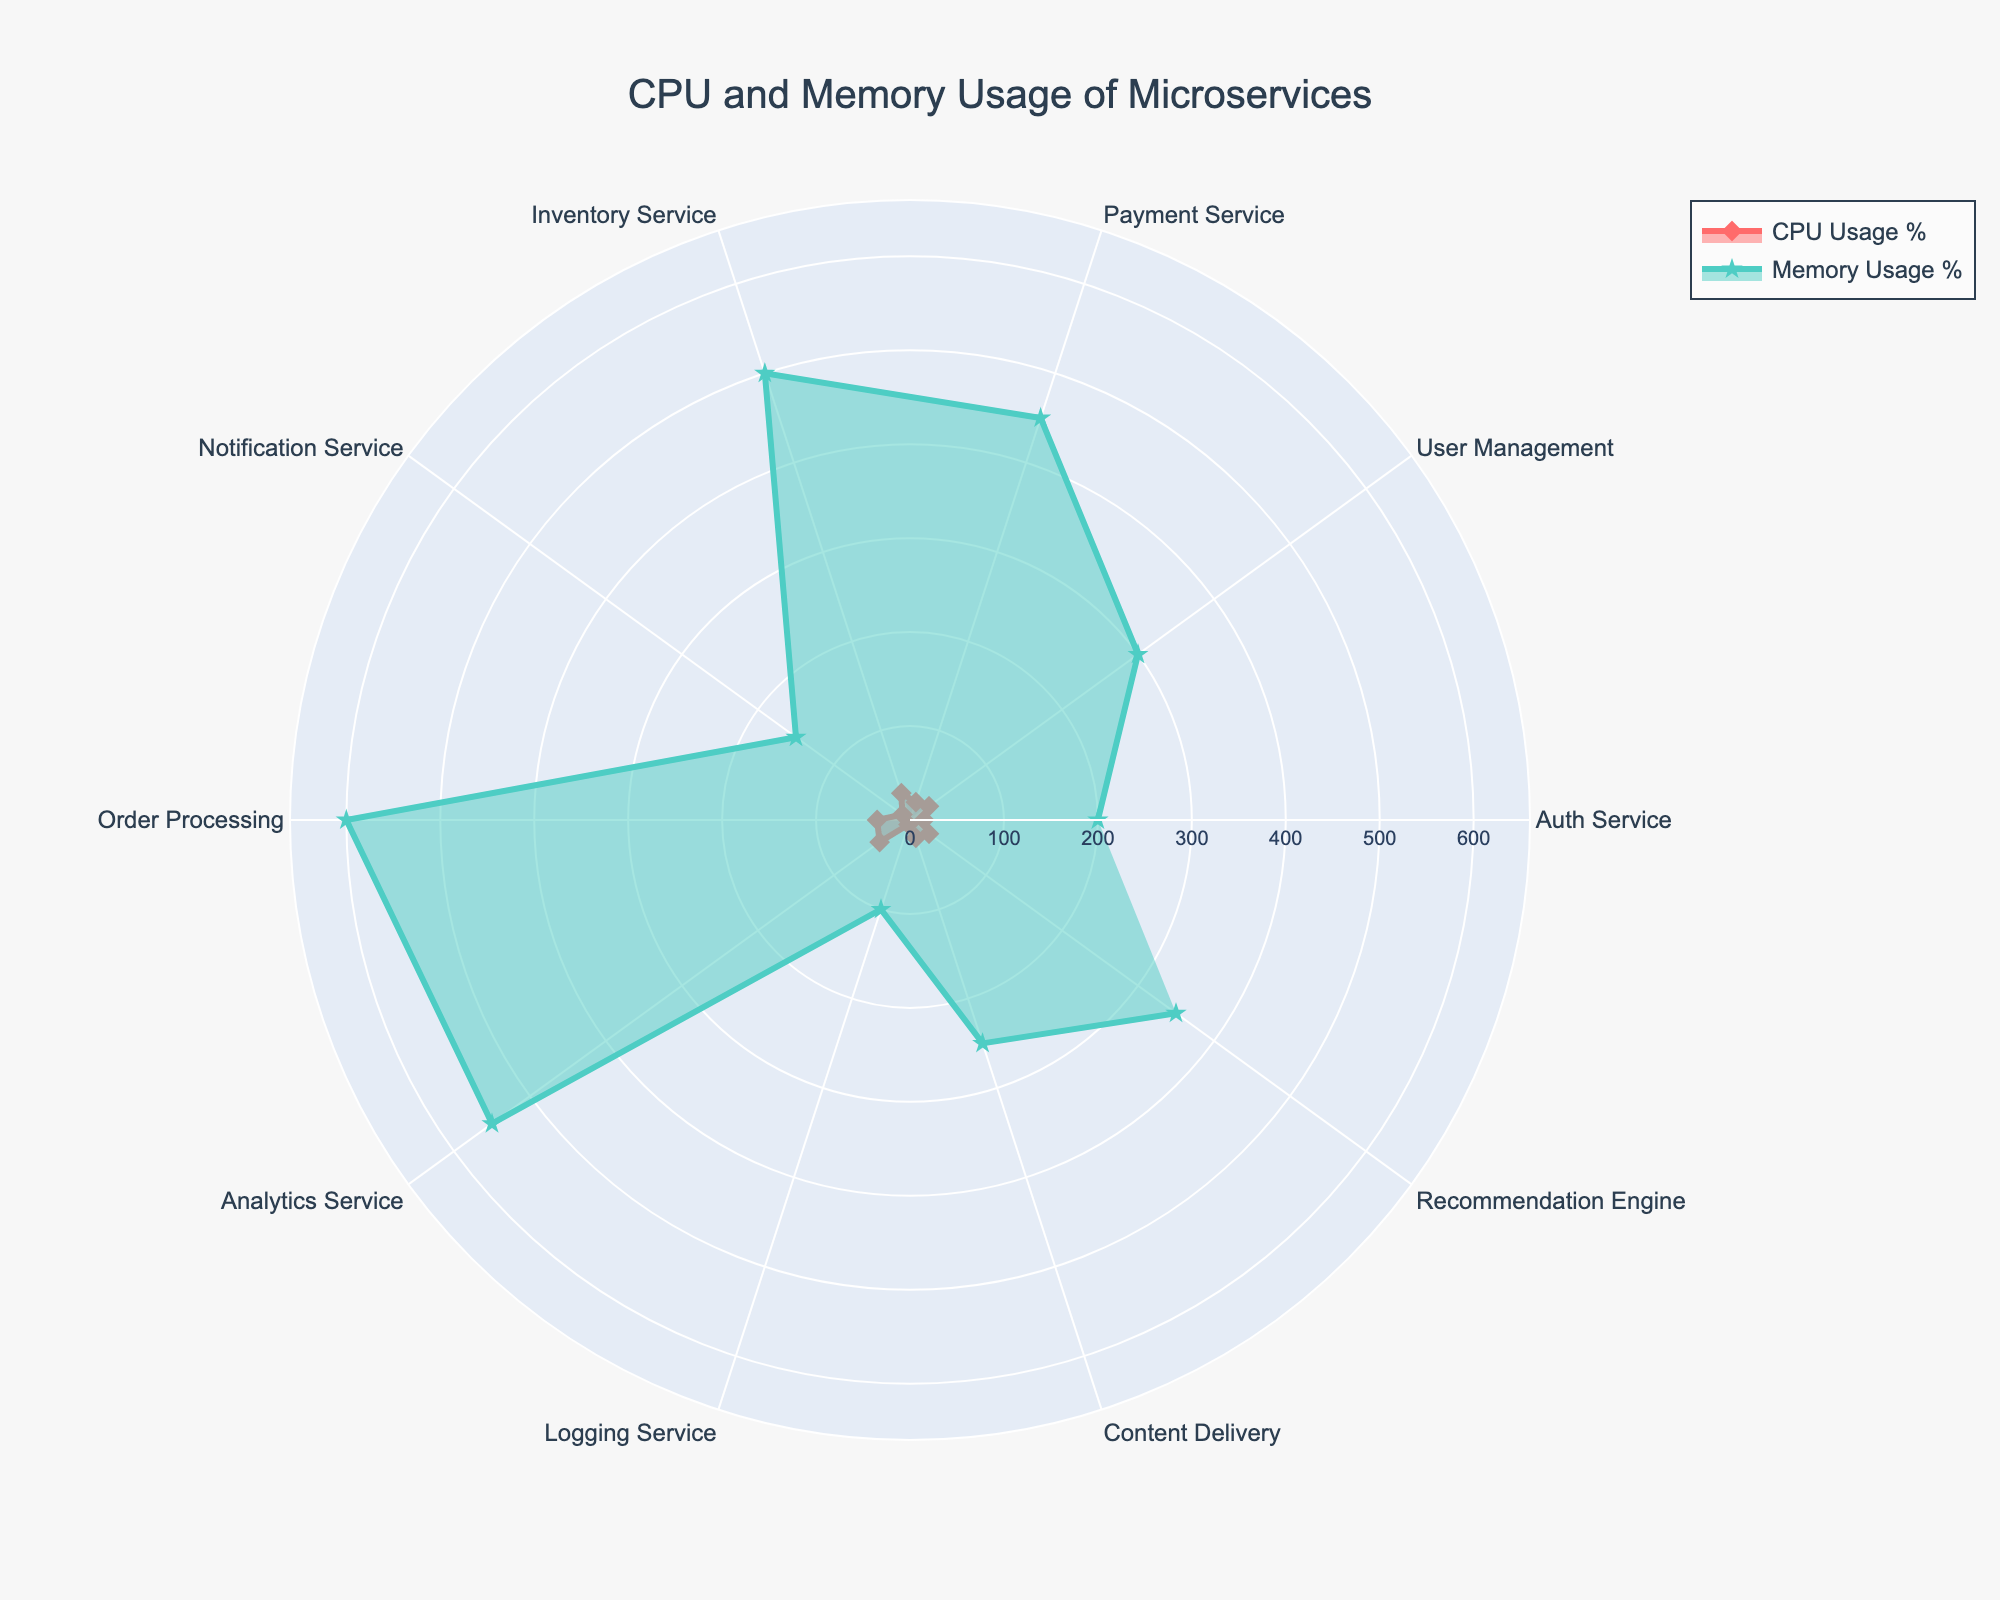What's the title of the radar chart? The title is located at the top center of the figure, typically larger in size than other text. It reads 'CPU and Memory Usage of Microservices'.
Answer: CPU and Memory Usage of Microservices How many services are displayed in the radar chart? Count the number of labels (services) on the radar chart. There are 10 distinct labels indicating each microservice.
Answer: 10 Which service has the highest CPU usage? Look for the data point that extends the furthest radially from the center along the 'CPU Usage %' axis. The 'Analytics Service' reaches the furthest point at 40%.
Answer: Analytics Service Which service uses the most memory? Look for the data point that extends the furthest radially from the center along the 'Memory Usage %' axis. The 'Order Processing' service reaches the furthest point at 600%.
Answer: Order Processing What is the difference in CPU usage between the 'Auth Service' and the 'Analytics Service'? The 'Auth Service' has a CPU usage of 15% and the 'Analytics Service' has 40%. Subtract the 'Auth Service' value from the 'Analytics Service' value: 40% - 15% = 25%.
Answer: 25% Which service shows the least CPU usage? Locate the smallest data point on the 'CPU Usage %' axis. The 'Logging Service' shows the smallest CPU usage at 5%.
Answer: Logging Service What is the average memory usage across all services? Sum the memory usage for all services: 200+300+450+500+150+600+550+100+250+350 = 3450. Then divide by the number of services, 10: 3450/10 = 345%.
Answer: 345 Which service's CPU and memory usage are almost the same? Find the service whose CPU and memory usage values are closest to each other. The 'Content Delivery' service has CPU usage at 20% and memory usage at 250%, with the smallest difference relative to other services.
Answer: Content Delivery Which two services have the most similar CPU usage? Identify the services with the closest CPU usage values. 'User Management' and 'Recommendation Engine' both have CPU usage at 25%.
Answer: User Management, Recommendation Engine What's the total CPU usage percentage of all services combined? Sum the CPU usage percentages for all services: 15+25+20+30+10+35+40+5+20+25 = 225%.
Answer: 225% 